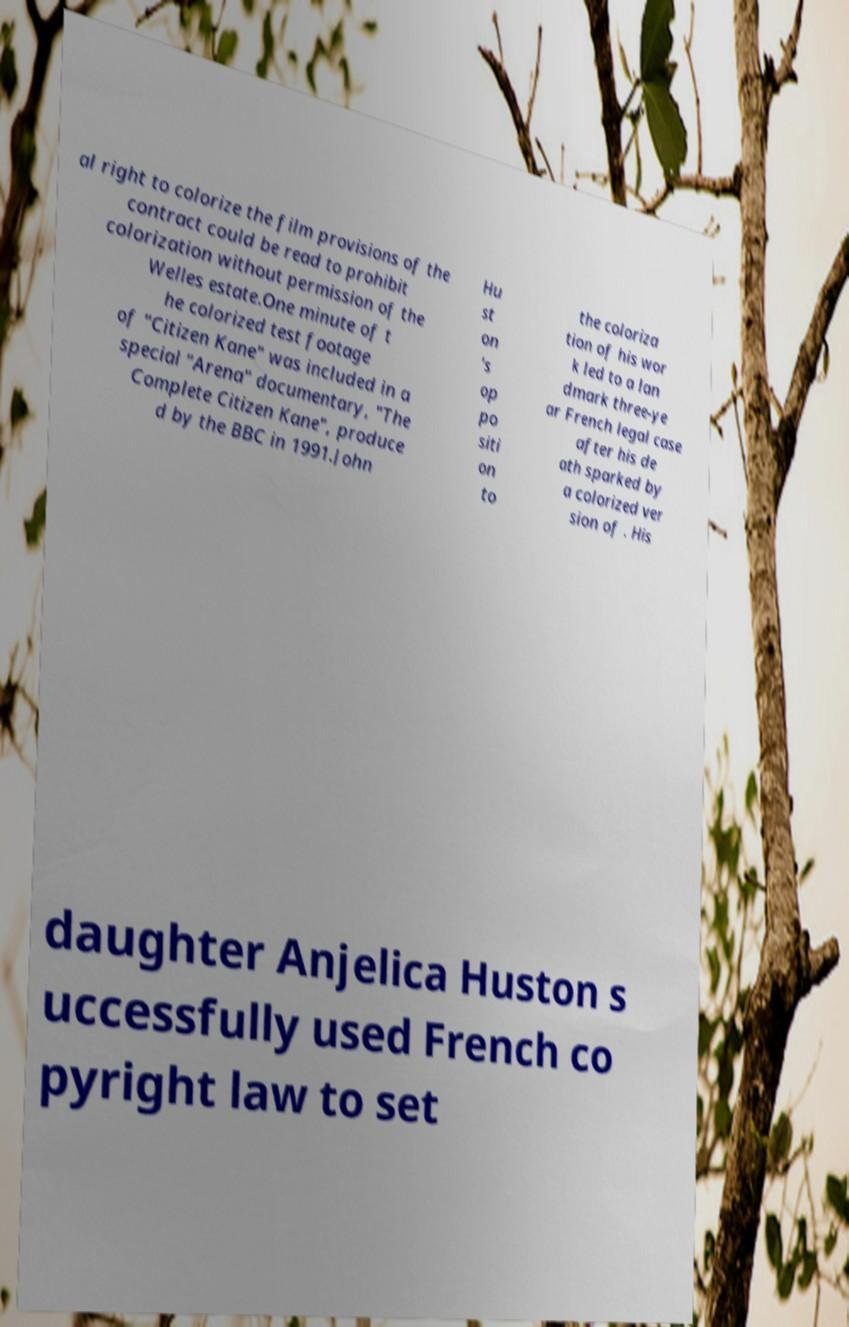There's text embedded in this image that I need extracted. Can you transcribe it verbatim? al right to colorize the film provisions of the contract could be read to prohibit colorization without permission of the Welles estate.One minute of t he colorized test footage of "Citizen Kane" was included in a special "Arena" documentary, "The Complete Citizen Kane", produce d by the BBC in 1991.John Hu st on 's op po siti on to the coloriza tion of his wor k led to a lan dmark three-ye ar French legal case after his de ath sparked by a colorized ver sion of . His daughter Anjelica Huston s uccessfully used French co pyright law to set 